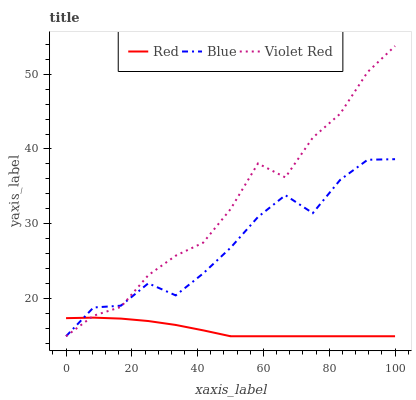Does Red have the minimum area under the curve?
Answer yes or no. Yes. Does Violet Red have the maximum area under the curve?
Answer yes or no. Yes. Does Violet Red have the minimum area under the curve?
Answer yes or no. No. Does Red have the maximum area under the curve?
Answer yes or no. No. Is Red the smoothest?
Answer yes or no. Yes. Is Blue the roughest?
Answer yes or no. Yes. Is Violet Red the smoothest?
Answer yes or no. No. Is Violet Red the roughest?
Answer yes or no. No. Does Blue have the lowest value?
Answer yes or no. Yes. Does Violet Red have the highest value?
Answer yes or no. Yes. Does Red have the highest value?
Answer yes or no. No. Does Violet Red intersect Blue?
Answer yes or no. Yes. Is Violet Red less than Blue?
Answer yes or no. No. Is Violet Red greater than Blue?
Answer yes or no. No. 